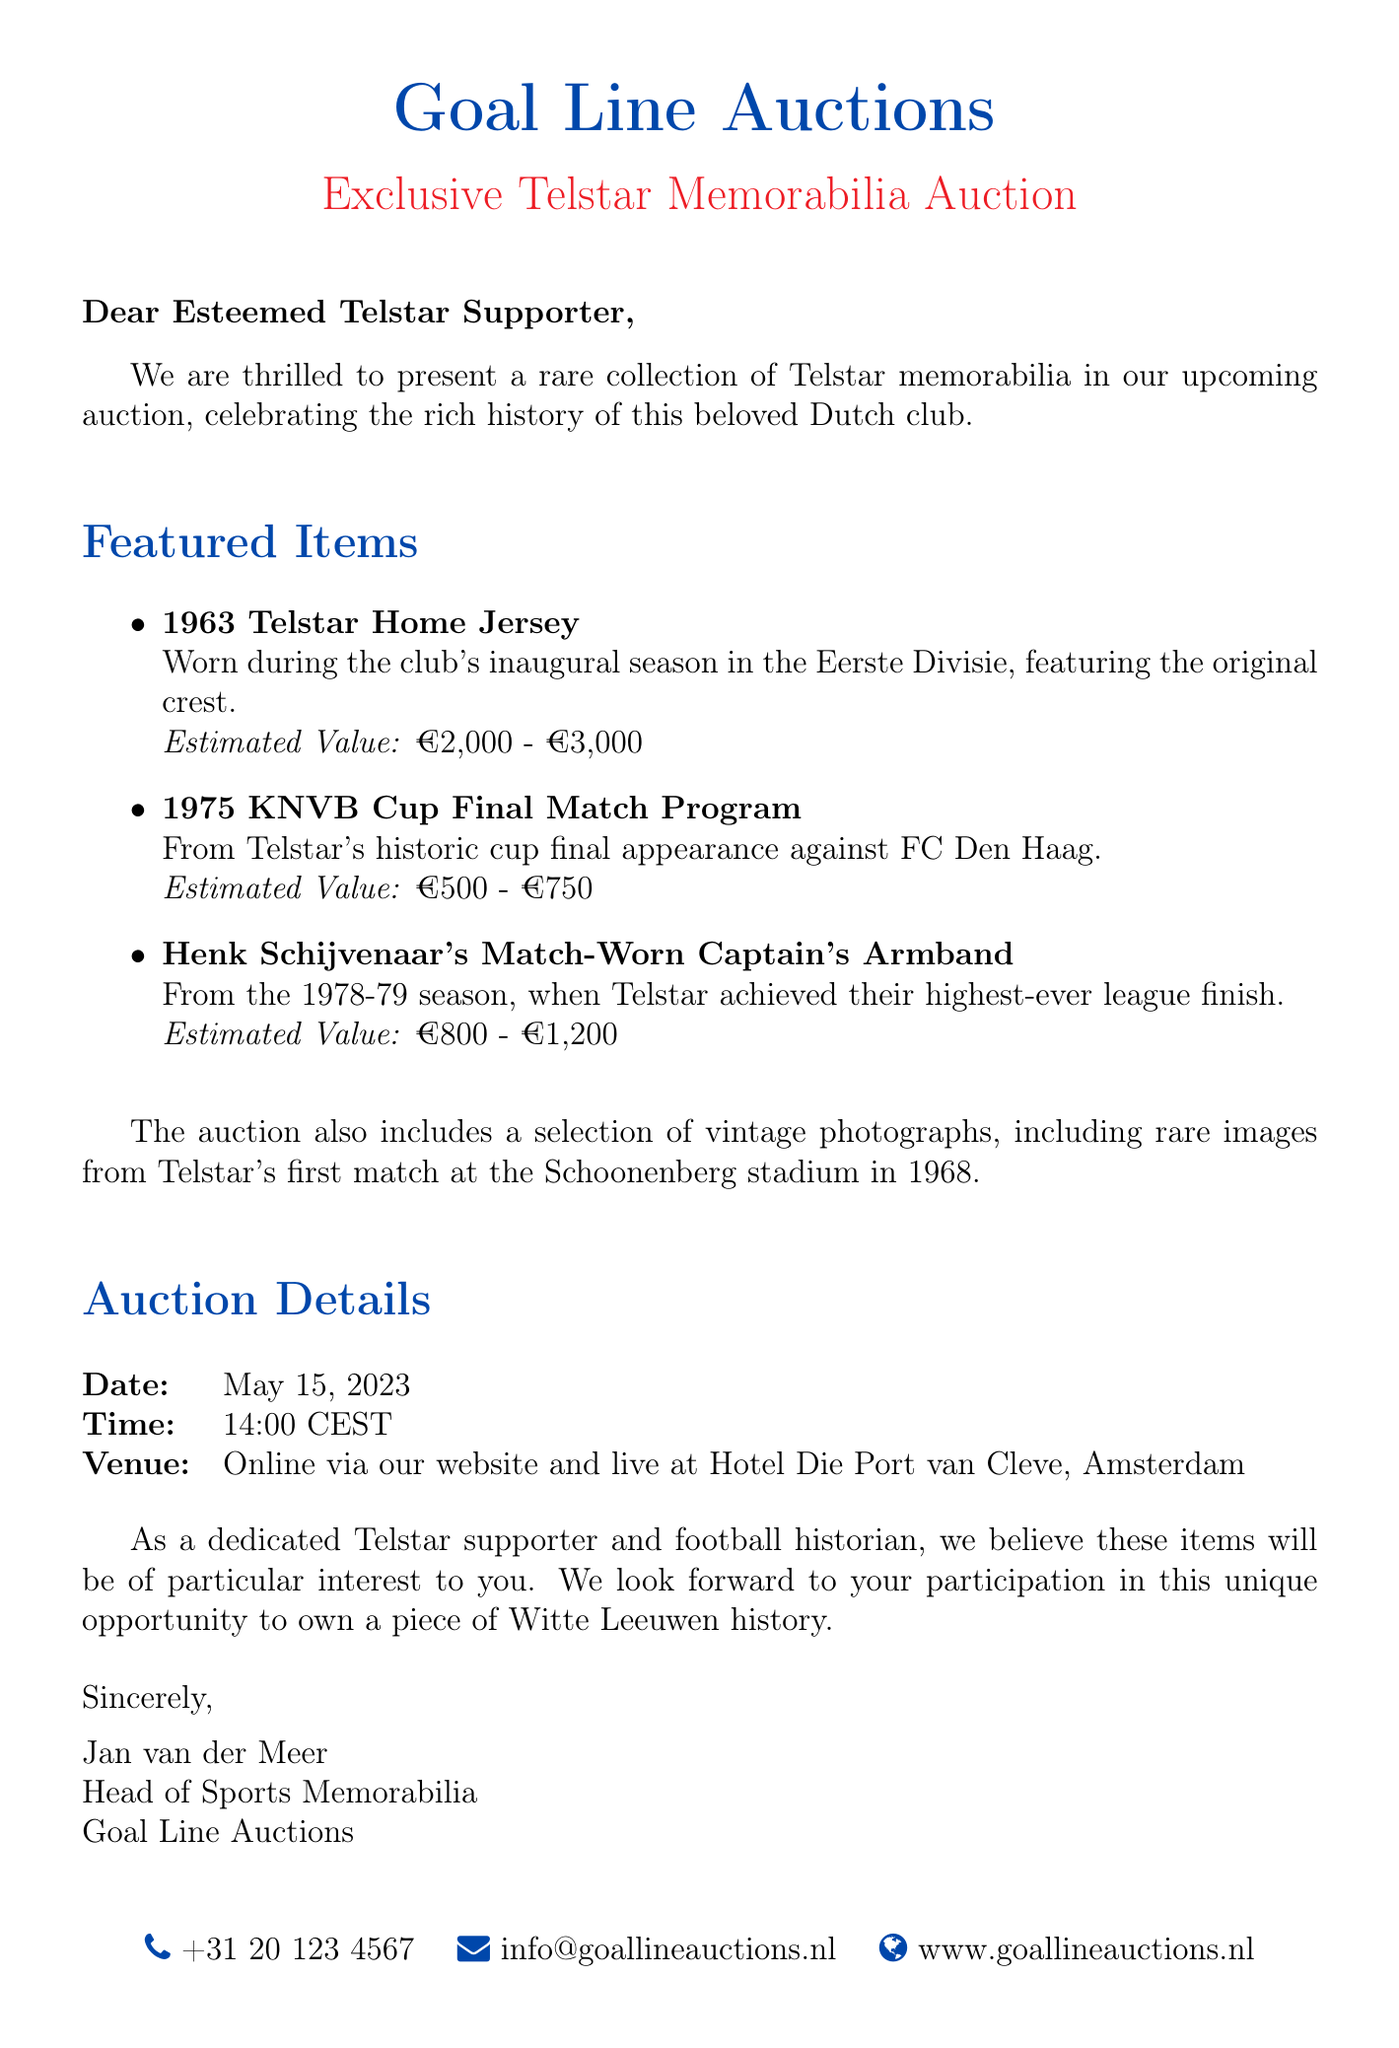What is the date of the auction? The date of the auction is mentioned clearly in the document under auction details.
Answer: May 15, 2023 Who wrote the email? The document specifies the name and title of the sender at the end of the email.
Answer: Jan van der Meer What is the estimated value of the 1963 Telstar Home Jersey? The document lists the estimated value for this item in the featured items section.
Answer: €2,000 - €3,000 Where is the auction venue for the live event? The document describes the venue location for the auction within the auction details section.
Answer: Hotel Die Port van Cleve, Amsterdam What historical event does the 1975 KNVB Cup Final Match Program pertain to? The description of the item indicates it relates to a specific match participatory event.
Answer: Telstar's historic cup final appearance What was the highest league finish achieved by Telstar mentioned in the document? The description of the captain's armband details the season related to a notable finish by the club.
Answer: Highest-ever league finish How many featured items are listed in the email? The document provides a list of items under the featured items section, which can be counted.
Answer: Three 